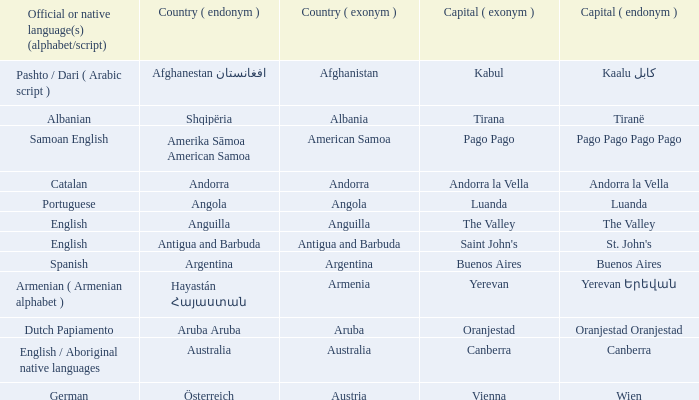What is the local name given to the capital of Anguilla? The Valley. 